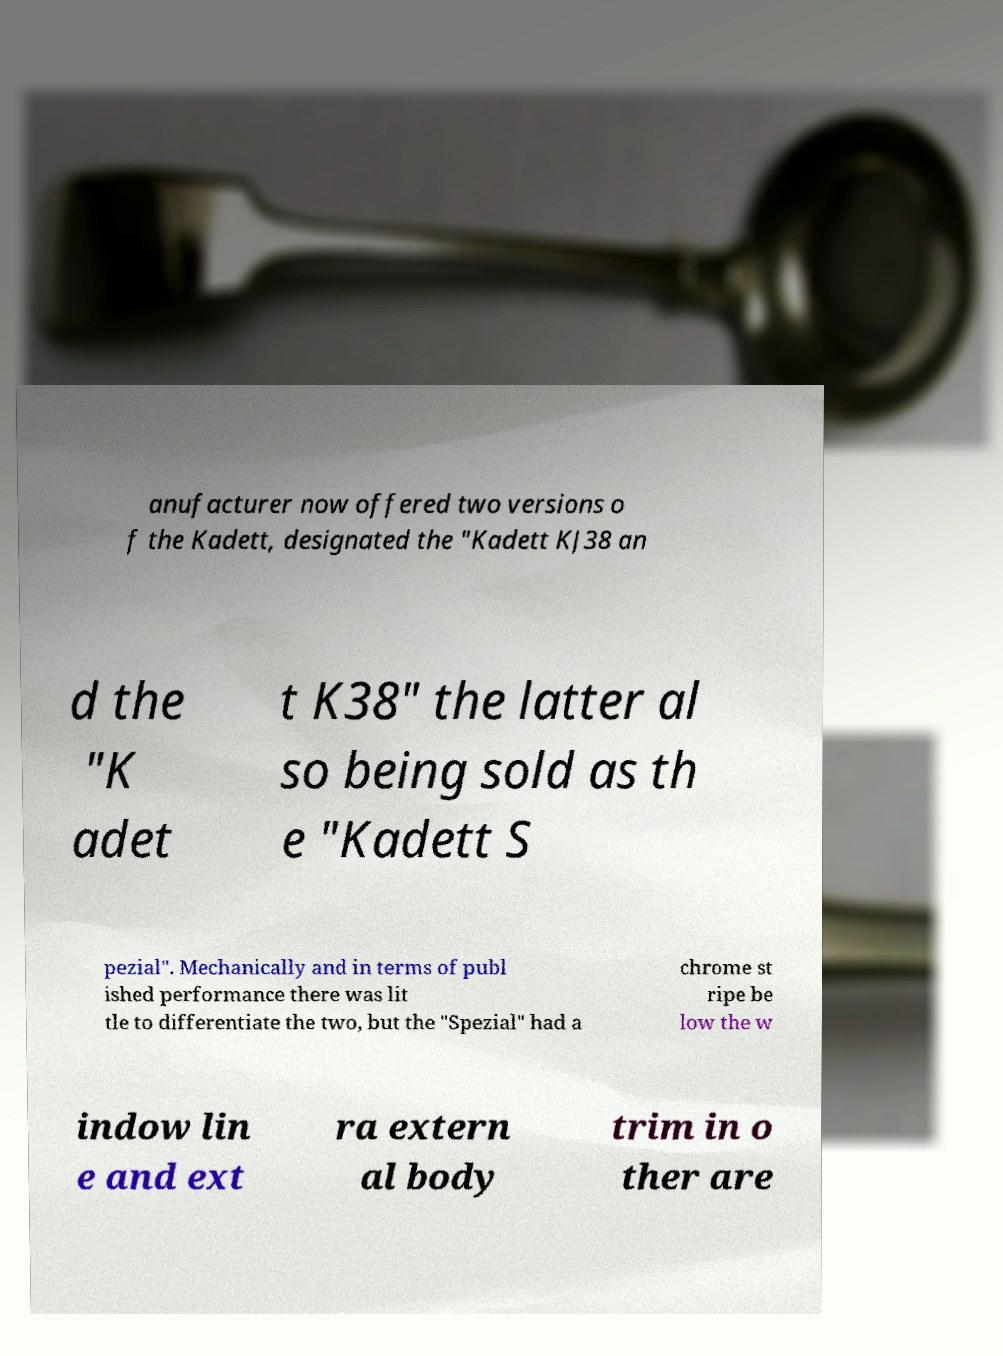There's text embedded in this image that I need extracted. Can you transcribe it verbatim? anufacturer now offered two versions o f the Kadett, designated the "Kadett KJ38 an d the "K adet t K38" the latter al so being sold as th e "Kadett S pezial". Mechanically and in terms of publ ished performance there was lit tle to differentiate the two, but the "Spezial" had a chrome st ripe be low the w indow lin e and ext ra extern al body trim in o ther are 